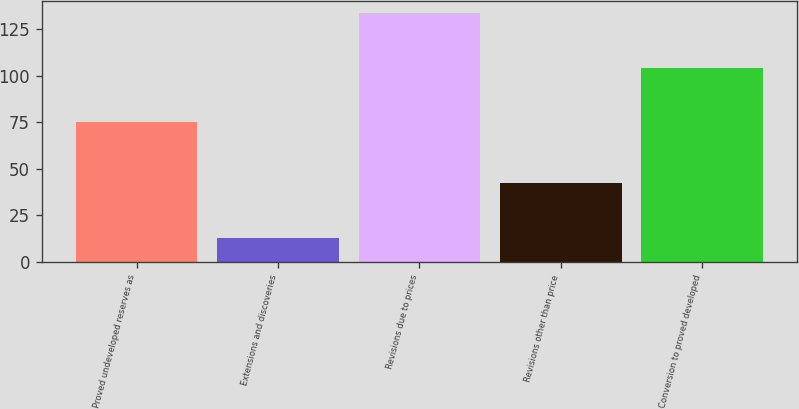Convert chart to OTSL. <chart><loc_0><loc_0><loc_500><loc_500><bar_chart><fcel>Proved undeveloped reserves as<fcel>Extensions and discoveries<fcel>Revisions due to prices<fcel>Revisions other than price<fcel>Conversion to proved developed<nl><fcel>75<fcel>13<fcel>133.4<fcel>42.2<fcel>104.2<nl></chart> 